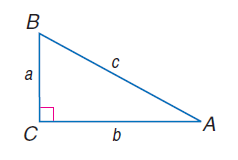Answer the mathemtical geometry problem and directly provide the correct option letter.
Question: a = 8, b = 15, and c = 17, find \tan B.
Choices: A: 1.23 B: 1.67 C: 1.88 D: 2.43 C 